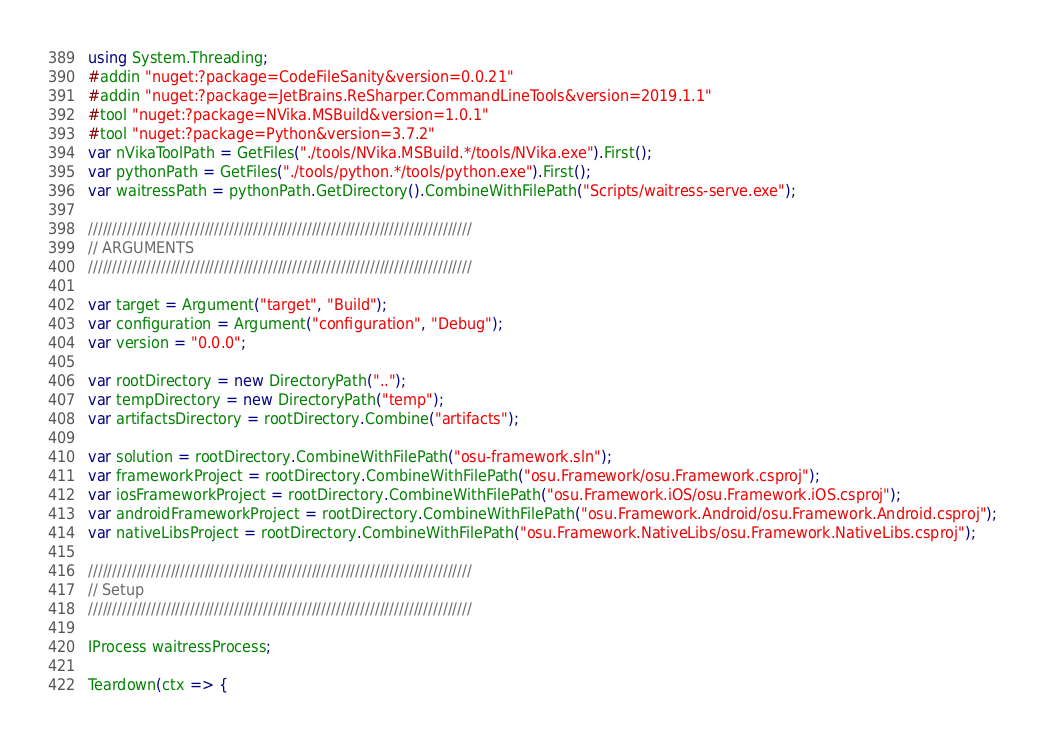Convert code to text. <code><loc_0><loc_0><loc_500><loc_500><_C#_>using System.Threading;
#addin "nuget:?package=CodeFileSanity&version=0.0.21"
#addin "nuget:?package=JetBrains.ReSharper.CommandLineTools&version=2019.1.1"
#tool "nuget:?package=NVika.MSBuild&version=1.0.1"
#tool "nuget:?package=Python&version=3.7.2"
var nVikaToolPath = GetFiles("./tools/NVika.MSBuild.*/tools/NVika.exe").First();
var pythonPath = GetFiles("./tools/python.*/tools/python.exe").First();
var waitressPath = pythonPath.GetDirectory().CombineWithFilePath("Scripts/waitress-serve.exe");

///////////////////////////////////////////////////////////////////////////////
// ARGUMENTS
///////////////////////////////////////////////////////////////////////////////

var target = Argument("target", "Build");
var configuration = Argument("configuration", "Debug");
var version = "0.0.0";

var rootDirectory = new DirectoryPath("..");
var tempDirectory = new DirectoryPath("temp");
var artifactsDirectory = rootDirectory.Combine("artifacts");

var solution = rootDirectory.CombineWithFilePath("osu-framework.sln");
var frameworkProject = rootDirectory.CombineWithFilePath("osu.Framework/osu.Framework.csproj");
var iosFrameworkProject = rootDirectory.CombineWithFilePath("osu.Framework.iOS/osu.Framework.iOS.csproj");
var androidFrameworkProject = rootDirectory.CombineWithFilePath("osu.Framework.Android/osu.Framework.Android.csproj");
var nativeLibsProject = rootDirectory.CombineWithFilePath("osu.Framework.NativeLibs/osu.Framework.NativeLibs.csproj");

///////////////////////////////////////////////////////////////////////////////
// Setup
///////////////////////////////////////////////////////////////////////////////

IProcess waitressProcess;

Teardown(ctx => {</code> 